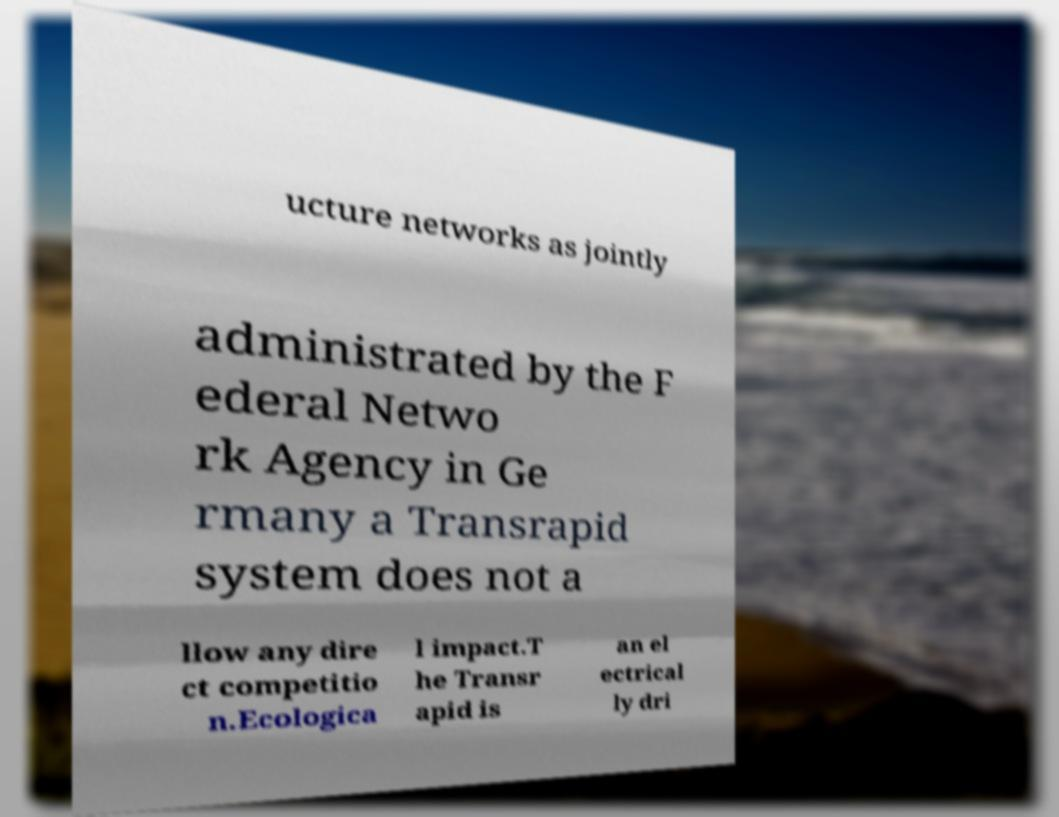Can you accurately transcribe the text from the provided image for me? ucture networks as jointly administrated by the F ederal Netwo rk Agency in Ge rmany a Transrapid system does not a llow any dire ct competitio n.Ecologica l impact.T he Transr apid is an el ectrical ly dri 